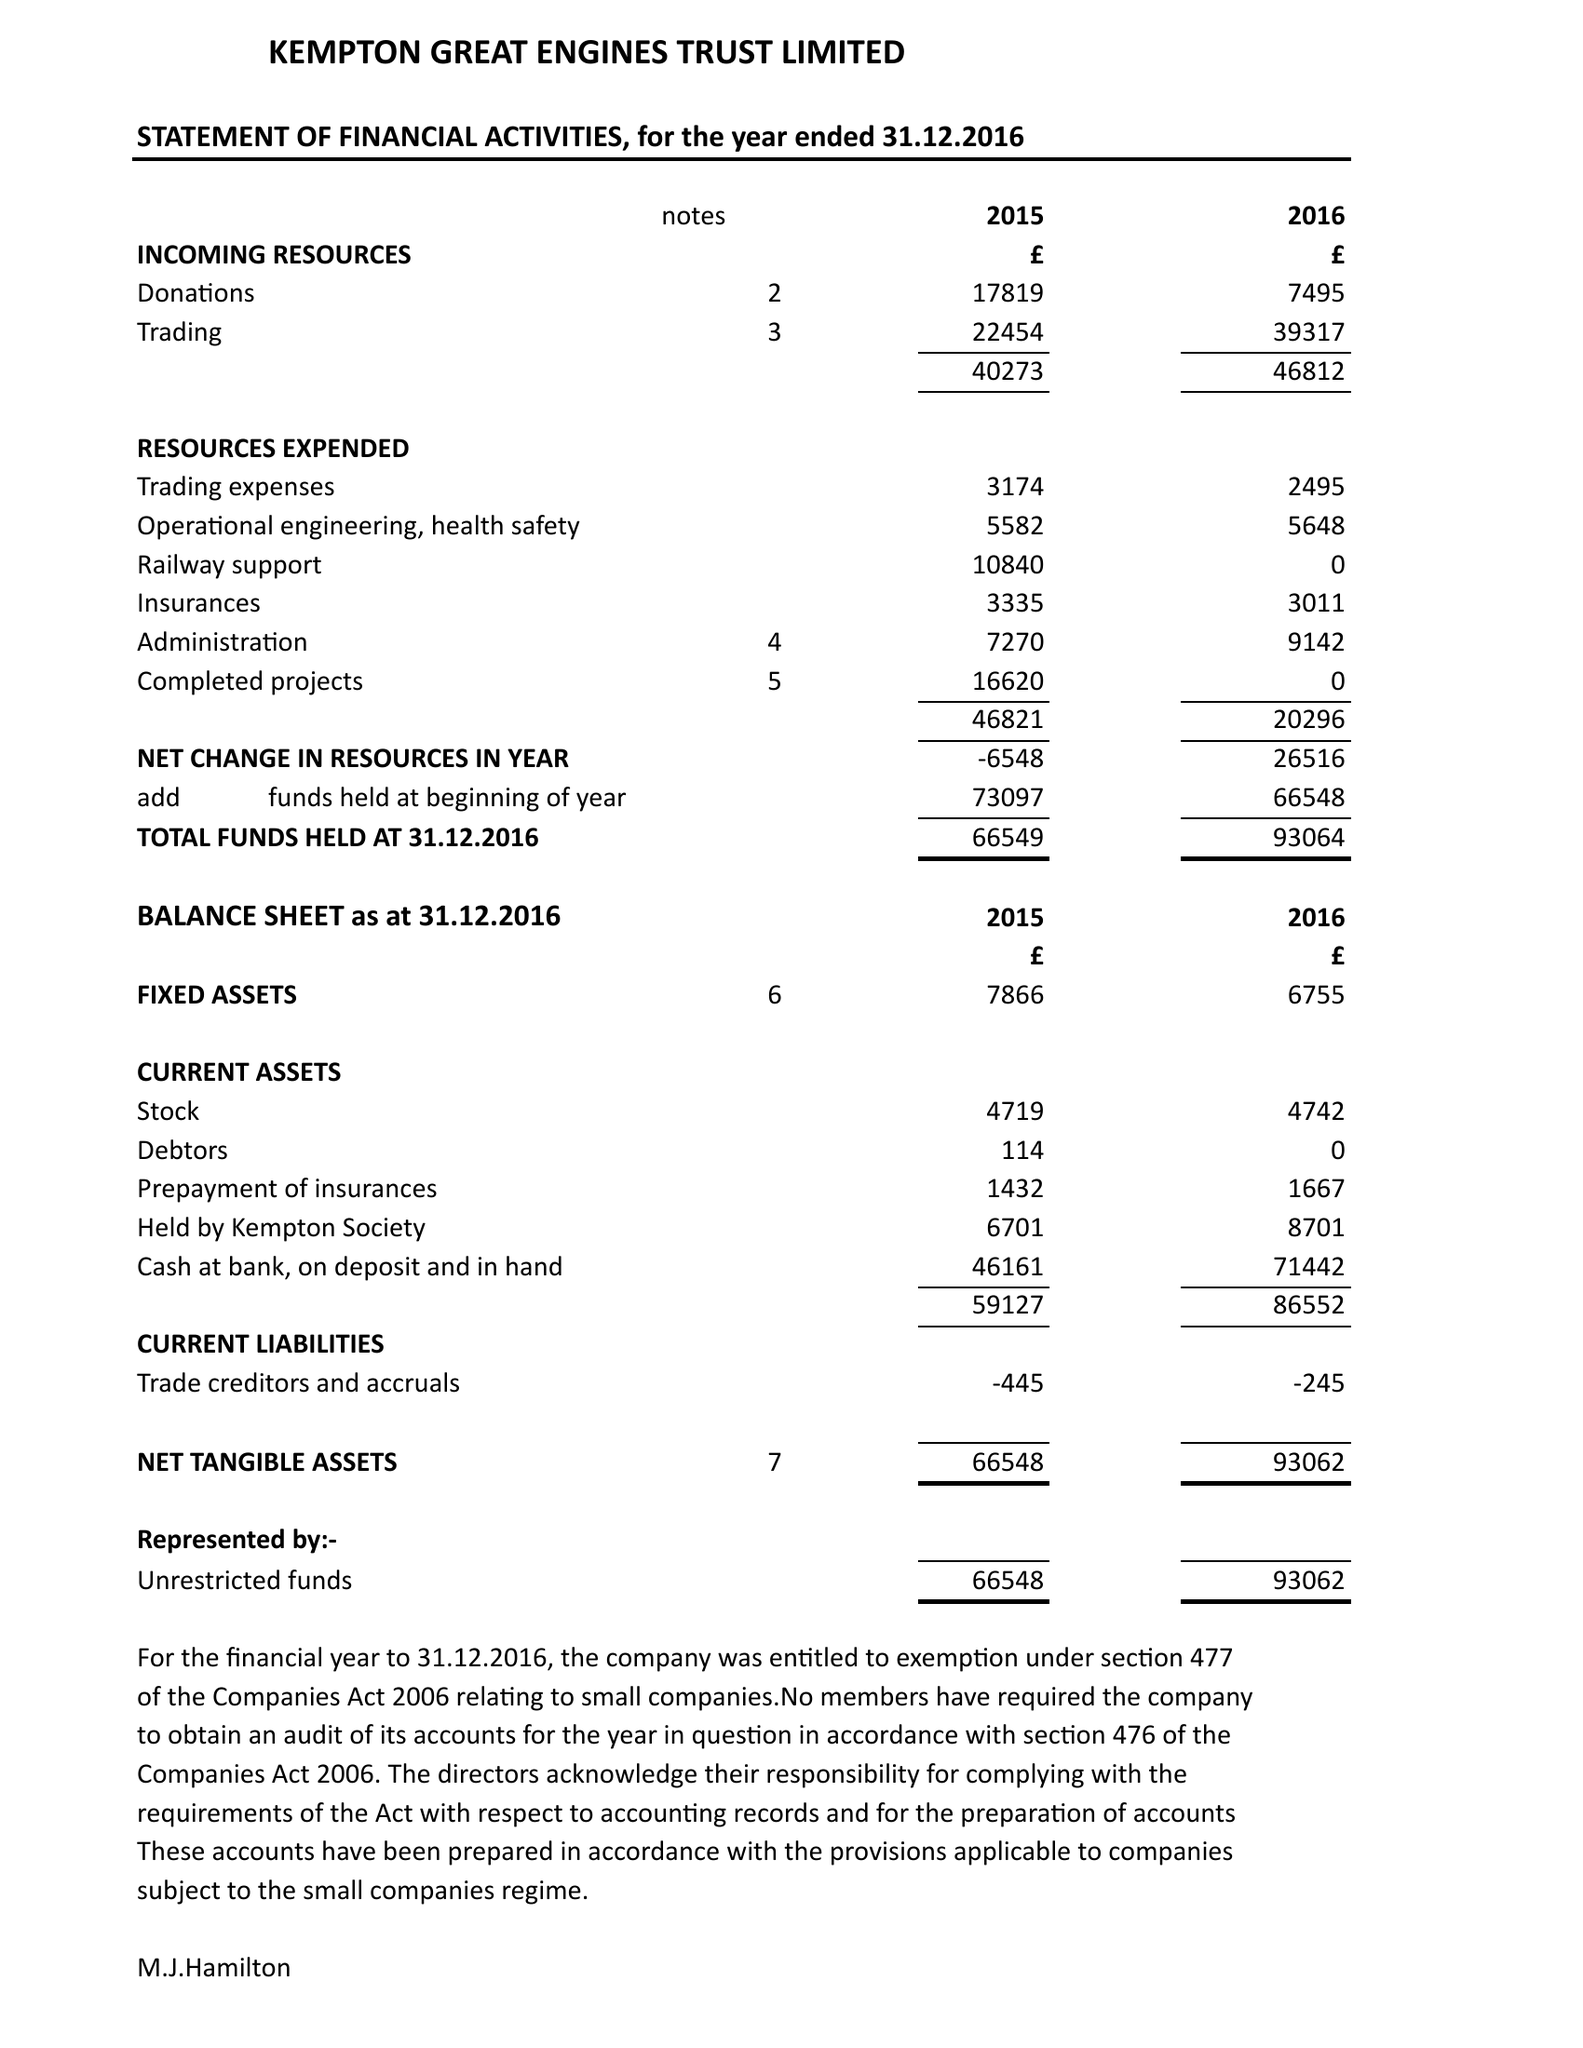What is the value for the address__street_line?
Answer the question using a single word or phrase. SNAKEY LANE 